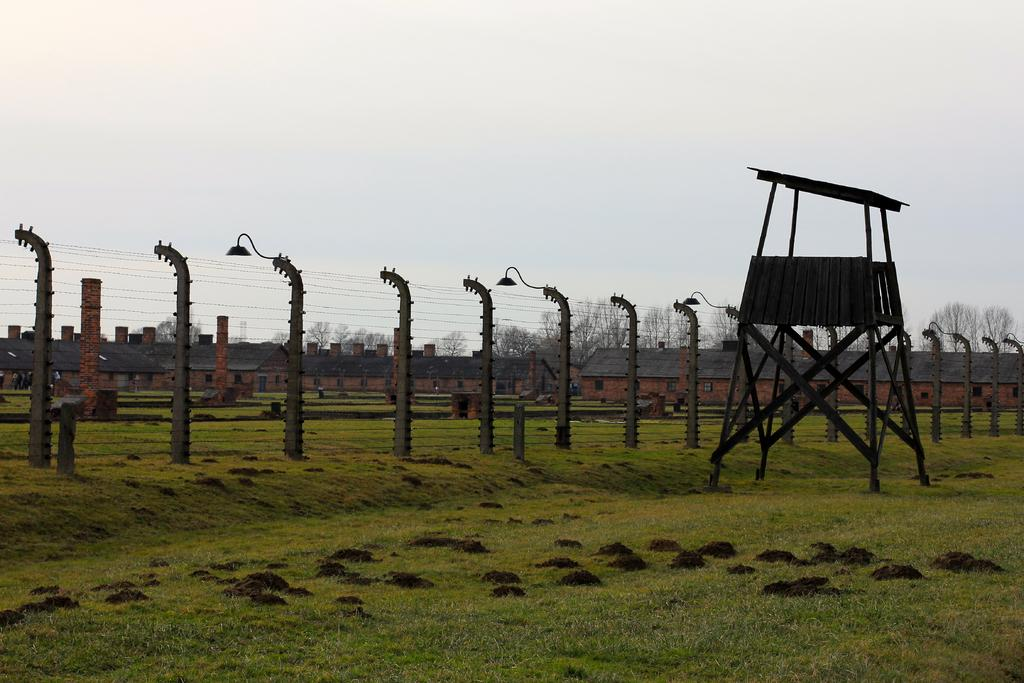What type of surface is on the ground in the image? There is grass on the ground in the image. What is the fencing made of, and what is its structure? The fencing has poles, and it is made of a material that is not specified in the facts. What is the purpose of the lights on the poles? The purpose of the lights on the poles is not specified in the facts. What is the wooden stand used for? The wooden stand's purpose is not specified in the facts. What can be seen in the background of the image? In the background of the image, there are buildings, trees, and the sky. How many crates of pizzas are visible in the image? There are no crates of pizzas present in the image. What type of plants are growing on the wooden stand? There are no plants growing on the wooden stand in the image. 